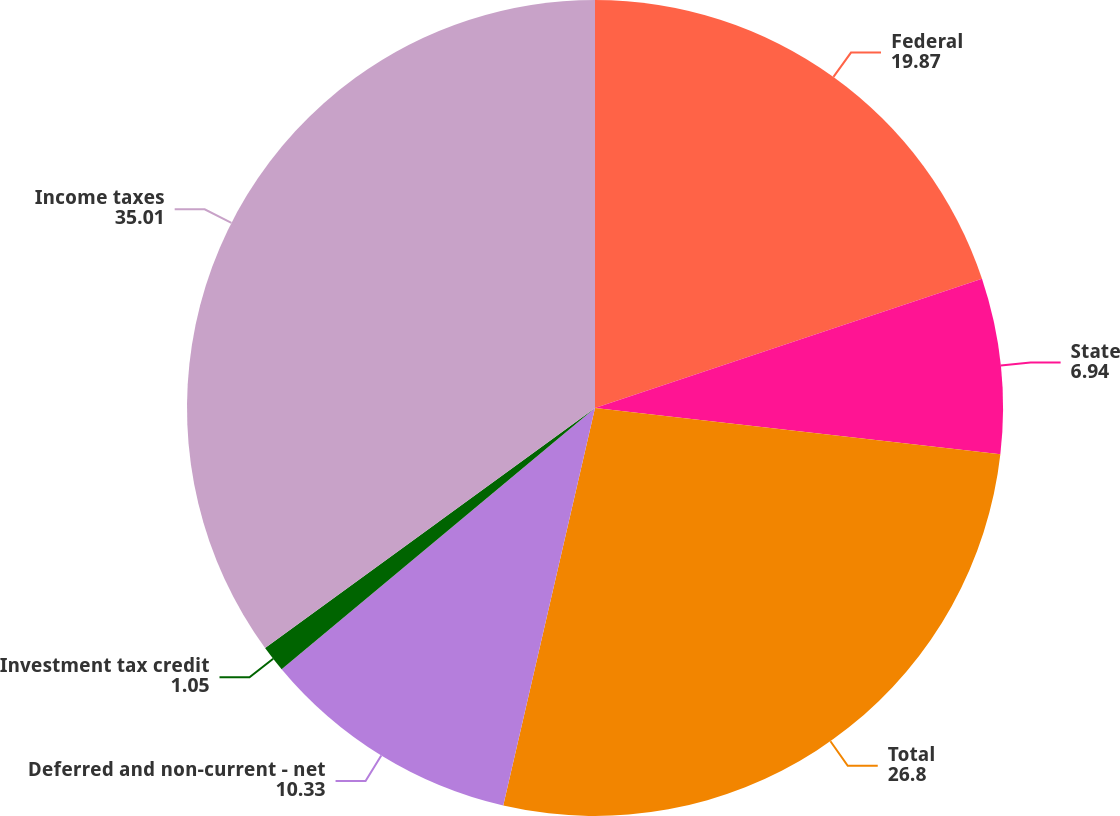Convert chart to OTSL. <chart><loc_0><loc_0><loc_500><loc_500><pie_chart><fcel>Federal<fcel>State<fcel>Total<fcel>Deferred and non-current - net<fcel>Investment tax credit<fcel>Income taxes<nl><fcel>19.87%<fcel>6.94%<fcel>26.8%<fcel>10.33%<fcel>1.05%<fcel>35.01%<nl></chart> 